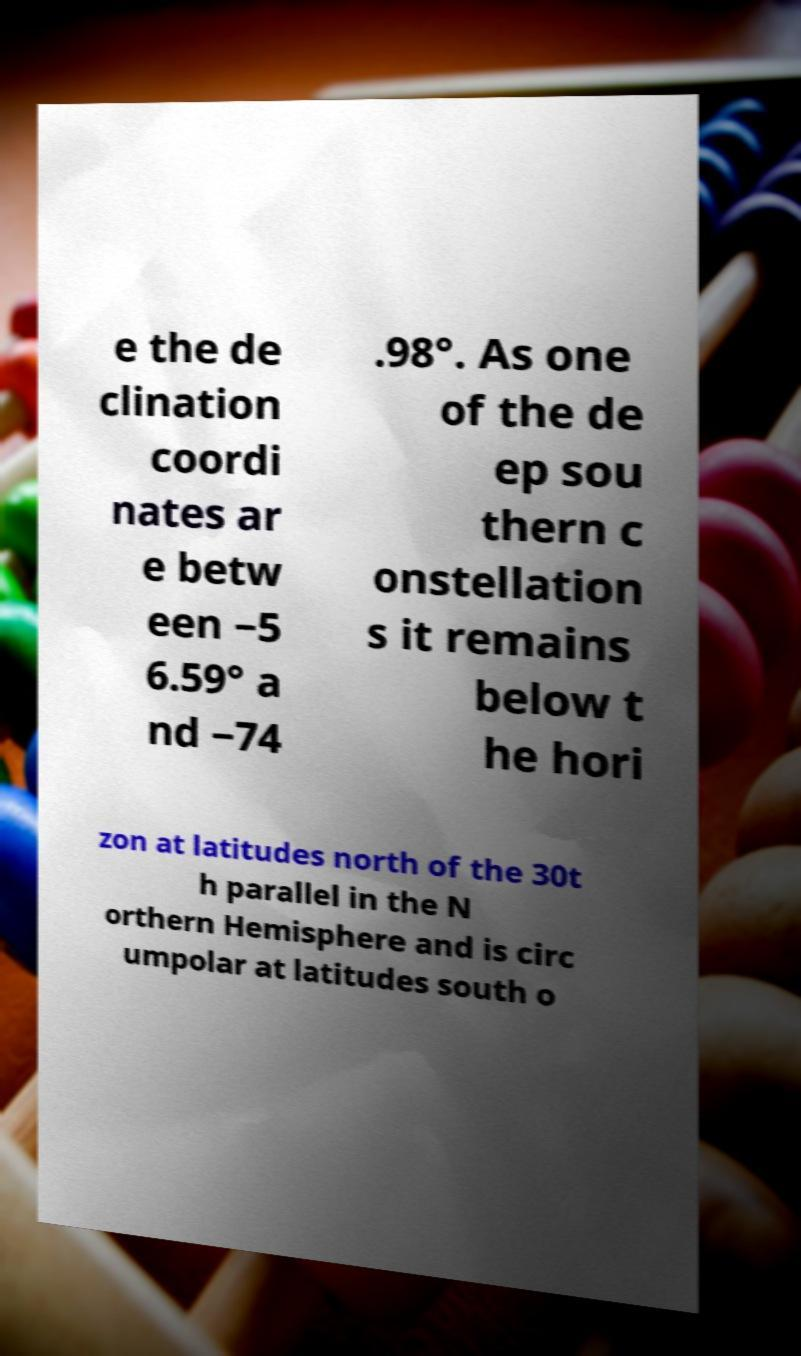There's text embedded in this image that I need extracted. Can you transcribe it verbatim? e the de clination coordi nates ar e betw een −5 6.59° a nd −74 .98°. As one of the de ep sou thern c onstellation s it remains below t he hori zon at latitudes north of the 30t h parallel in the N orthern Hemisphere and is circ umpolar at latitudes south o 